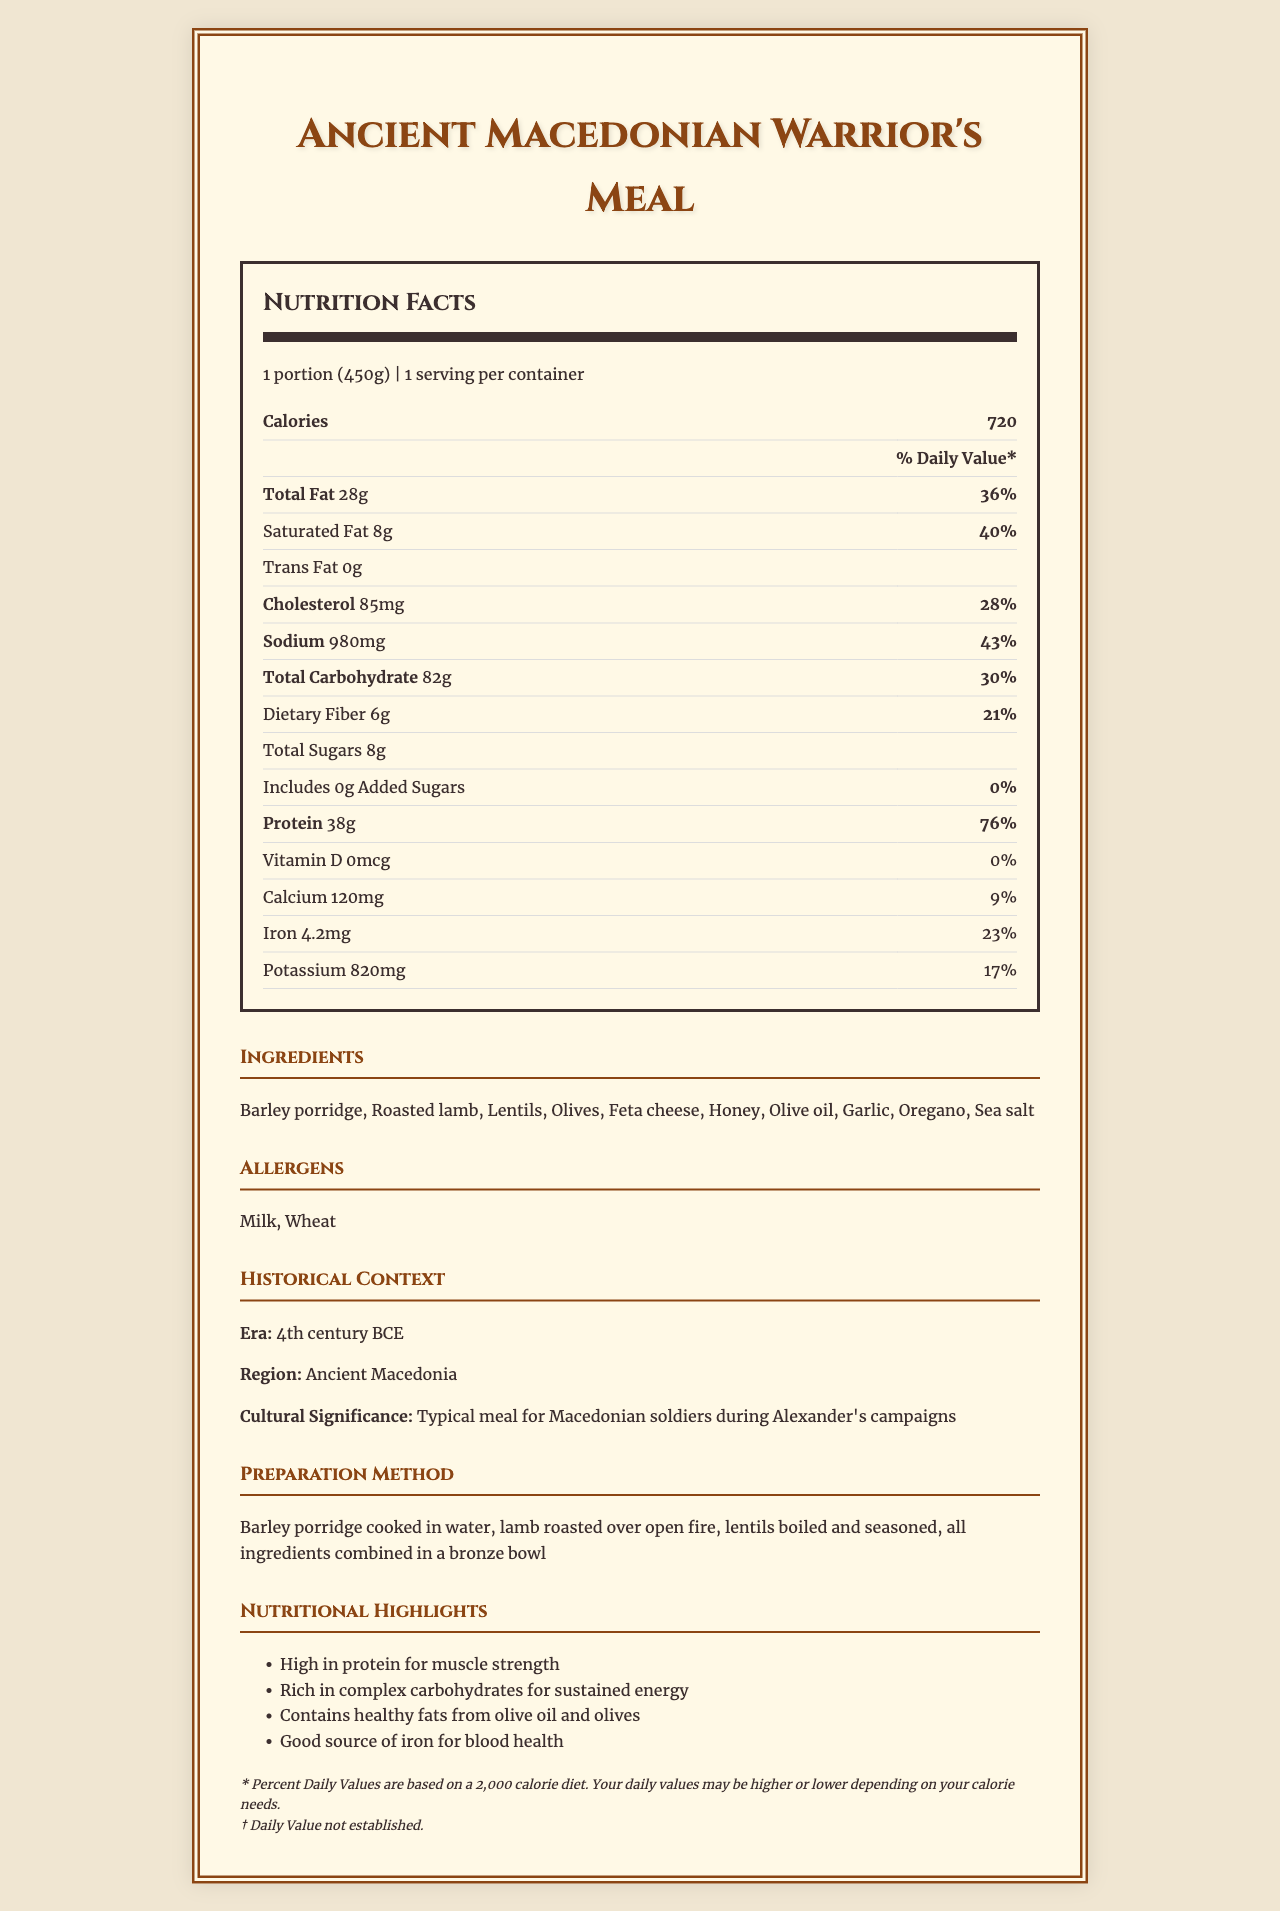what is the serving size for the Ancient Macedonian Warrior's Meal? The serving size is indicated at the beginning of the Nutrition Facts section.
Answer: 1 portion (450g) how many calories are there per serving? The calories per serving are listed under the Nutrition Facts section.
Answer: 720 list two primary ingredients of the meal The primary ingredients are mentioned under the Ingredients section.
Answer: Barley porridge, Roasted lamb what are the allergens present in the meal? The allergens are explicitly listed in the Allergens section.
Answer: Milk, Wheat what is the source of complex carbohydrates in the meal? According to the Nutritional Highlights section, complex carbohydrates come from barley porridge.
Answer: Barley porridge how much protein does one serving contain and its daily value percentage? The amount of protein is 38g and its daily value percentage is 76% as listed in the Nutrition Facts section.
Answer: 38g, 76% how is the food prepared? A. Boiled in water B. Roasted in an oven C. Roasted over open fire The food is prepared by roasting lamb over an open fire, as described in the Preparation Method section.
Answer: C. Roasted over open fire what era is this meal from? A. 5th century BCE B. 4th century BCE C. 3rd century BCE D. 2nd century BCE The era is stated as the 4th century BCE in the Historical Context section.
Answer: B. 4th century BCE which is not a nutritional highlight of the meal? A. High in protein B. Contains vitamin D C. Rich in complex carbohydrates D. Good source of iron The Nutritional Highlights do not mention vitamin D; in fact, vitamin D content is 0.
Answer: B. Contains vitamin D does the meal include added sugars? The amount of added sugars is listed as 0g in the Nutrition Facts section.
Answer: No summarize the main idea of the document. The explanation encompasses all key sections of the document, giving a holistic view of the meal’s nutritional and historical significance.
Answer: The document provides comprehensive nutrition information for an Ancient Macedonian Warrior's Meal from the 4th century BCE. It includes details about serving size, calories, macronutrients, micronutrients, ingredients, allergens, historical context, preparation method, and nutritional highlights, illustrating a well-rounded traditional meal for Macedonian soldiers during Alexander’s campaigns. how much trans fat is in the meal? While the trans fat amount is listed as 0g, the visual information in the document does not confirm this without reliance on data.
Answer: Cannot be determined how much saturated fat is there, and what is its daily value percentage? The amount of saturated fat is 8g and its daily value percentage is 40% as indicated in the Nutrition Facts section.
Answer: 8g, 40% 